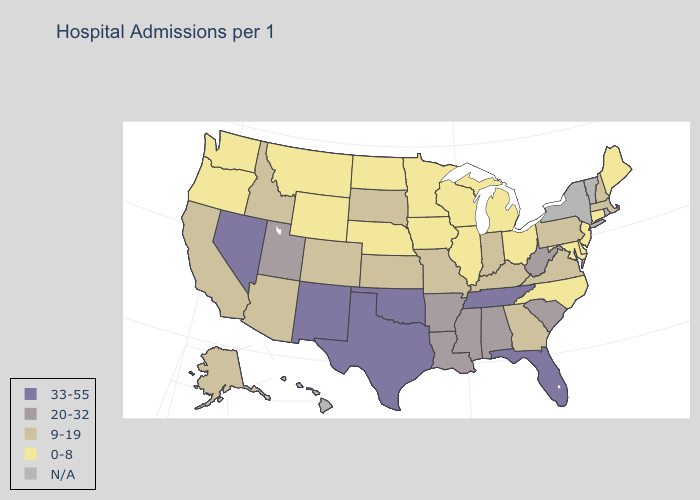Name the states that have a value in the range 9-19?
Concise answer only. Alaska, Arizona, California, Colorado, Georgia, Idaho, Indiana, Kansas, Kentucky, Massachusetts, Missouri, New Hampshire, Pennsylvania, South Dakota, Virginia. Which states have the lowest value in the USA?
Concise answer only. Connecticut, Delaware, Illinois, Iowa, Maine, Maryland, Michigan, Minnesota, Montana, Nebraska, New Jersey, North Carolina, North Dakota, Ohio, Oregon, Washington, Wisconsin, Wyoming. Among the states that border Florida , does Georgia have the highest value?
Short answer required. No. Does Maine have the highest value in the Northeast?
Answer briefly. No. Name the states that have a value in the range 0-8?
Quick response, please. Connecticut, Delaware, Illinois, Iowa, Maine, Maryland, Michigan, Minnesota, Montana, Nebraska, New Jersey, North Carolina, North Dakota, Ohio, Oregon, Washington, Wisconsin, Wyoming. Does Delaware have the lowest value in the South?
Be succinct. Yes. What is the value of Minnesota?
Keep it brief. 0-8. Name the states that have a value in the range 9-19?
Quick response, please. Alaska, Arizona, California, Colorado, Georgia, Idaho, Indiana, Kansas, Kentucky, Massachusetts, Missouri, New Hampshire, Pennsylvania, South Dakota, Virginia. What is the value of Maryland?
Give a very brief answer. 0-8. Does Tennessee have the highest value in the USA?
Keep it brief. Yes. Does the map have missing data?
Answer briefly. Yes. What is the value of Georgia?
Answer briefly. 9-19. What is the lowest value in the South?
Short answer required. 0-8. Name the states that have a value in the range N/A?
Keep it brief. Hawaii, New York, Rhode Island, Vermont. 